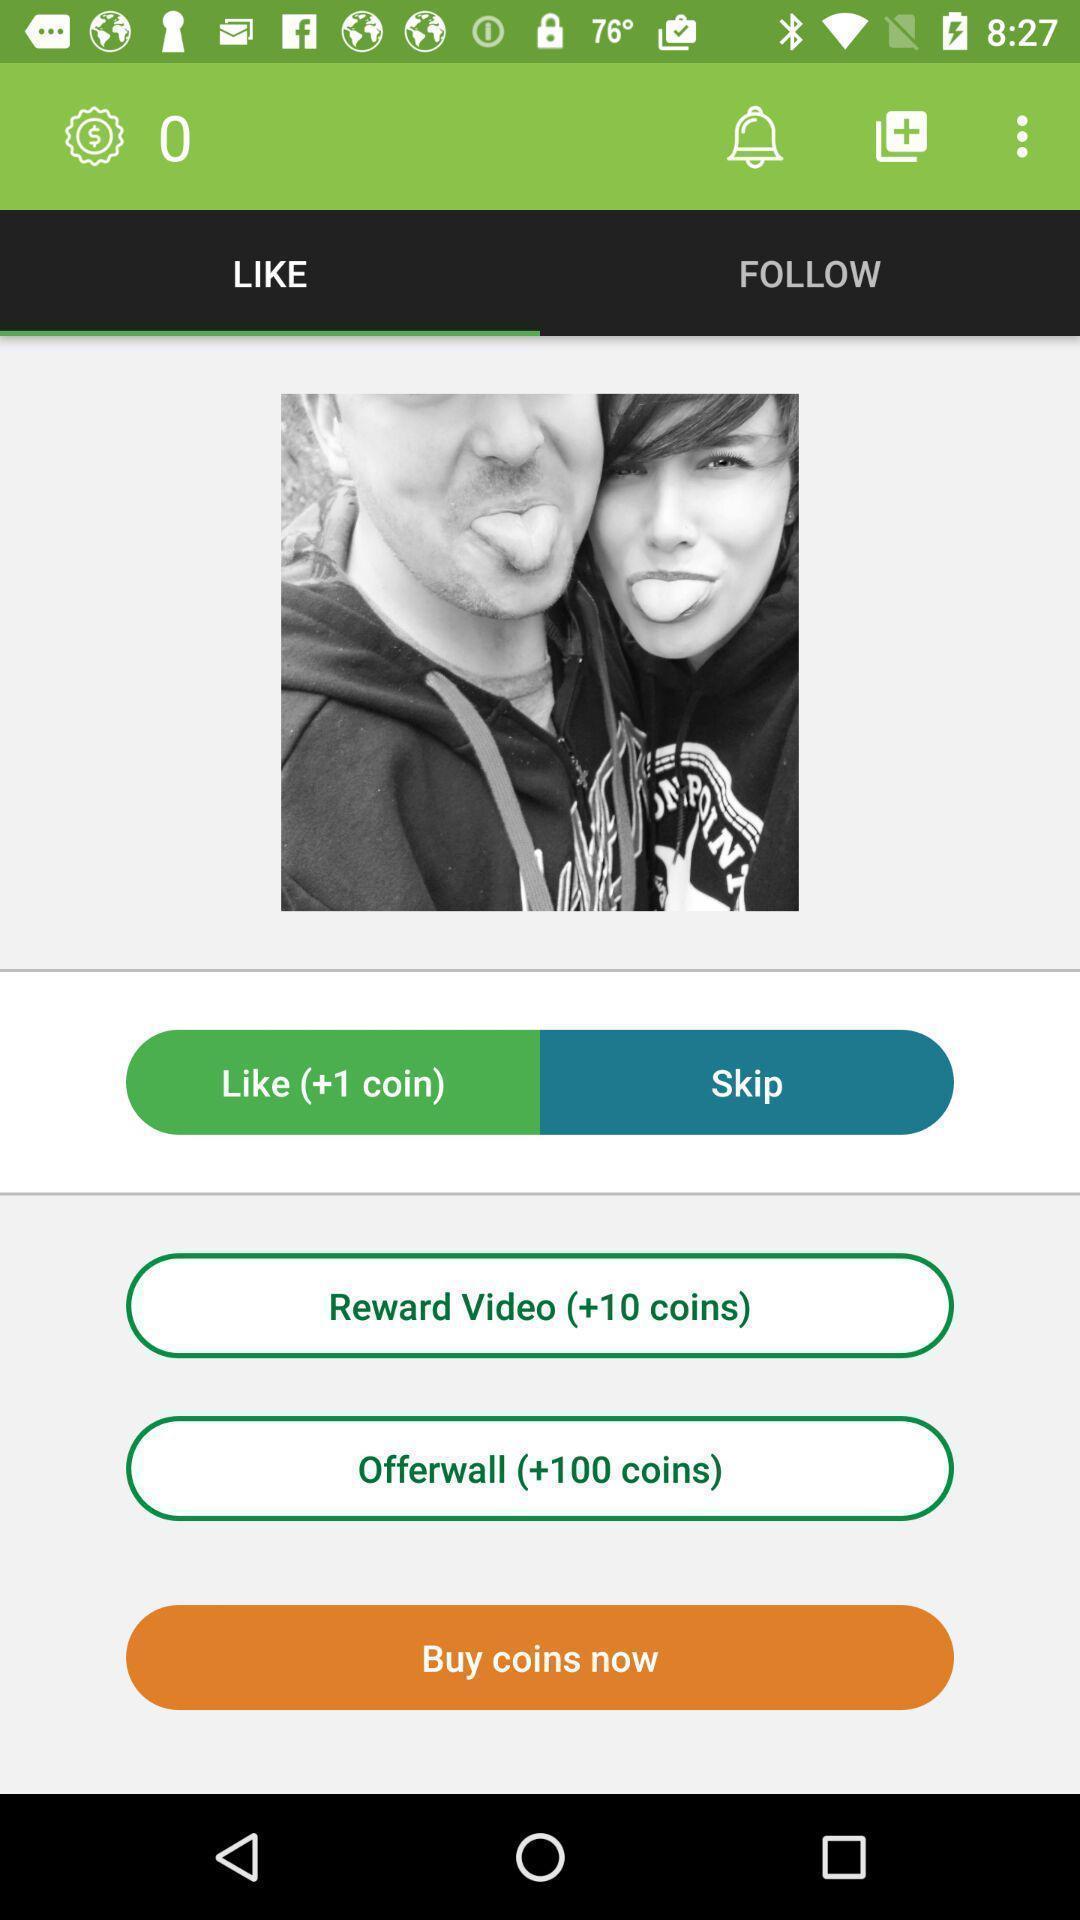Describe the visual elements of this screenshot. Screen asking to buy coins on a video. 